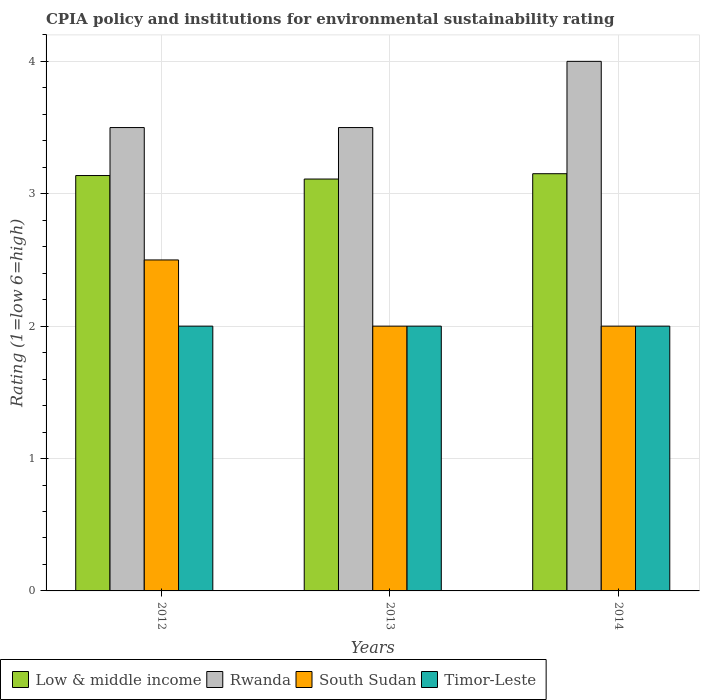How many groups of bars are there?
Provide a succinct answer. 3. Are the number of bars per tick equal to the number of legend labels?
Make the answer very short. Yes. Are the number of bars on each tick of the X-axis equal?
Offer a terse response. Yes. What is the CPIA rating in Timor-Leste in 2012?
Provide a short and direct response. 2. Across all years, what is the minimum CPIA rating in Timor-Leste?
Give a very brief answer. 2. What is the difference between the CPIA rating in Timor-Leste in 2012 and that in 2013?
Provide a succinct answer. 0. In the year 2014, what is the difference between the CPIA rating in Timor-Leste and CPIA rating in Low & middle income?
Keep it short and to the point. -1.15. In how many years, is the CPIA rating in Timor-Leste greater than 2?
Offer a terse response. 0. What is the ratio of the CPIA rating in Low & middle income in 2012 to that in 2014?
Offer a very short reply. 1. What is the difference between the highest and the lowest CPIA rating in South Sudan?
Give a very brief answer. 0.5. In how many years, is the CPIA rating in Timor-Leste greater than the average CPIA rating in Timor-Leste taken over all years?
Provide a succinct answer. 0. What does the 4th bar from the left in 2013 represents?
Ensure brevity in your answer.  Timor-Leste. What does the 1st bar from the right in 2012 represents?
Give a very brief answer. Timor-Leste. Is it the case that in every year, the sum of the CPIA rating in South Sudan and CPIA rating in Timor-Leste is greater than the CPIA rating in Low & middle income?
Offer a terse response. Yes. How many bars are there?
Give a very brief answer. 12. Are all the bars in the graph horizontal?
Keep it short and to the point. No. What is the difference between two consecutive major ticks on the Y-axis?
Your answer should be very brief. 1. Does the graph contain any zero values?
Your answer should be very brief. No. Where does the legend appear in the graph?
Your answer should be very brief. Bottom left. How many legend labels are there?
Give a very brief answer. 4. What is the title of the graph?
Provide a short and direct response. CPIA policy and institutions for environmental sustainability rating. Does "Niger" appear as one of the legend labels in the graph?
Your answer should be compact. No. What is the label or title of the X-axis?
Offer a very short reply. Years. What is the label or title of the Y-axis?
Give a very brief answer. Rating (1=low 6=high). What is the Rating (1=low 6=high) in Low & middle income in 2012?
Provide a succinct answer. 3.14. What is the Rating (1=low 6=high) in Rwanda in 2012?
Ensure brevity in your answer.  3.5. What is the Rating (1=low 6=high) of Timor-Leste in 2012?
Give a very brief answer. 2. What is the Rating (1=low 6=high) in Low & middle income in 2013?
Offer a very short reply. 3.11. What is the Rating (1=low 6=high) of Low & middle income in 2014?
Keep it short and to the point. 3.15. Across all years, what is the maximum Rating (1=low 6=high) of Low & middle income?
Your response must be concise. 3.15. Across all years, what is the maximum Rating (1=low 6=high) of Rwanda?
Your response must be concise. 4. Across all years, what is the maximum Rating (1=low 6=high) of Timor-Leste?
Offer a terse response. 2. Across all years, what is the minimum Rating (1=low 6=high) of Low & middle income?
Your response must be concise. 3.11. Across all years, what is the minimum Rating (1=low 6=high) in Rwanda?
Your response must be concise. 3.5. What is the total Rating (1=low 6=high) of Low & middle income in the graph?
Make the answer very short. 9.4. What is the total Rating (1=low 6=high) in South Sudan in the graph?
Your answer should be very brief. 6.5. What is the difference between the Rating (1=low 6=high) of Low & middle income in 2012 and that in 2013?
Offer a very short reply. 0.03. What is the difference between the Rating (1=low 6=high) in Rwanda in 2012 and that in 2013?
Provide a succinct answer. 0. What is the difference between the Rating (1=low 6=high) in South Sudan in 2012 and that in 2013?
Offer a terse response. 0.5. What is the difference between the Rating (1=low 6=high) of Timor-Leste in 2012 and that in 2013?
Provide a succinct answer. 0. What is the difference between the Rating (1=low 6=high) of Low & middle income in 2012 and that in 2014?
Offer a terse response. -0.01. What is the difference between the Rating (1=low 6=high) in South Sudan in 2012 and that in 2014?
Keep it short and to the point. 0.5. What is the difference between the Rating (1=low 6=high) of Timor-Leste in 2012 and that in 2014?
Your answer should be compact. 0. What is the difference between the Rating (1=low 6=high) in Low & middle income in 2013 and that in 2014?
Give a very brief answer. -0.04. What is the difference between the Rating (1=low 6=high) of Low & middle income in 2012 and the Rating (1=low 6=high) of Rwanda in 2013?
Your answer should be compact. -0.36. What is the difference between the Rating (1=low 6=high) of Low & middle income in 2012 and the Rating (1=low 6=high) of South Sudan in 2013?
Offer a terse response. 1.14. What is the difference between the Rating (1=low 6=high) in Low & middle income in 2012 and the Rating (1=low 6=high) in Timor-Leste in 2013?
Ensure brevity in your answer.  1.14. What is the difference between the Rating (1=low 6=high) of Rwanda in 2012 and the Rating (1=low 6=high) of Timor-Leste in 2013?
Your answer should be very brief. 1.5. What is the difference between the Rating (1=low 6=high) of Low & middle income in 2012 and the Rating (1=low 6=high) of Rwanda in 2014?
Keep it short and to the point. -0.86. What is the difference between the Rating (1=low 6=high) in Low & middle income in 2012 and the Rating (1=low 6=high) in South Sudan in 2014?
Your response must be concise. 1.14. What is the difference between the Rating (1=low 6=high) in Low & middle income in 2012 and the Rating (1=low 6=high) in Timor-Leste in 2014?
Offer a very short reply. 1.14. What is the difference between the Rating (1=low 6=high) of Rwanda in 2012 and the Rating (1=low 6=high) of Timor-Leste in 2014?
Give a very brief answer. 1.5. What is the difference between the Rating (1=low 6=high) of Low & middle income in 2013 and the Rating (1=low 6=high) of Rwanda in 2014?
Give a very brief answer. -0.89. What is the difference between the Rating (1=low 6=high) in Low & middle income in 2013 and the Rating (1=low 6=high) in Timor-Leste in 2014?
Give a very brief answer. 1.11. What is the difference between the Rating (1=low 6=high) of Rwanda in 2013 and the Rating (1=low 6=high) of Timor-Leste in 2014?
Offer a very short reply. 1.5. What is the difference between the Rating (1=low 6=high) in South Sudan in 2013 and the Rating (1=low 6=high) in Timor-Leste in 2014?
Keep it short and to the point. 0. What is the average Rating (1=low 6=high) of Low & middle income per year?
Ensure brevity in your answer.  3.13. What is the average Rating (1=low 6=high) of Rwanda per year?
Ensure brevity in your answer.  3.67. What is the average Rating (1=low 6=high) in South Sudan per year?
Make the answer very short. 2.17. In the year 2012, what is the difference between the Rating (1=low 6=high) in Low & middle income and Rating (1=low 6=high) in Rwanda?
Provide a short and direct response. -0.36. In the year 2012, what is the difference between the Rating (1=low 6=high) of Low & middle income and Rating (1=low 6=high) of South Sudan?
Ensure brevity in your answer.  0.64. In the year 2012, what is the difference between the Rating (1=low 6=high) in Low & middle income and Rating (1=low 6=high) in Timor-Leste?
Keep it short and to the point. 1.14. In the year 2012, what is the difference between the Rating (1=low 6=high) of Rwanda and Rating (1=low 6=high) of South Sudan?
Your answer should be compact. 1. In the year 2012, what is the difference between the Rating (1=low 6=high) of South Sudan and Rating (1=low 6=high) of Timor-Leste?
Your response must be concise. 0.5. In the year 2013, what is the difference between the Rating (1=low 6=high) in Low & middle income and Rating (1=low 6=high) in Rwanda?
Provide a short and direct response. -0.39. In the year 2013, what is the difference between the Rating (1=low 6=high) of Low & middle income and Rating (1=low 6=high) of South Sudan?
Offer a terse response. 1.11. In the year 2014, what is the difference between the Rating (1=low 6=high) in Low & middle income and Rating (1=low 6=high) in Rwanda?
Your answer should be compact. -0.85. In the year 2014, what is the difference between the Rating (1=low 6=high) of Low & middle income and Rating (1=low 6=high) of South Sudan?
Keep it short and to the point. 1.15. In the year 2014, what is the difference between the Rating (1=low 6=high) of Low & middle income and Rating (1=low 6=high) of Timor-Leste?
Your answer should be very brief. 1.15. In the year 2014, what is the difference between the Rating (1=low 6=high) in Rwanda and Rating (1=low 6=high) in Timor-Leste?
Offer a terse response. 2. What is the ratio of the Rating (1=low 6=high) in Low & middle income in 2012 to that in 2013?
Give a very brief answer. 1.01. What is the ratio of the Rating (1=low 6=high) in South Sudan in 2012 to that in 2013?
Ensure brevity in your answer.  1.25. What is the ratio of the Rating (1=low 6=high) in Timor-Leste in 2012 to that in 2013?
Keep it short and to the point. 1. What is the ratio of the Rating (1=low 6=high) of Rwanda in 2012 to that in 2014?
Your answer should be very brief. 0.88. What is the ratio of the Rating (1=low 6=high) of South Sudan in 2012 to that in 2014?
Offer a terse response. 1.25. What is the ratio of the Rating (1=low 6=high) of Low & middle income in 2013 to that in 2014?
Offer a very short reply. 0.99. What is the difference between the highest and the second highest Rating (1=low 6=high) in Low & middle income?
Make the answer very short. 0.01. What is the difference between the highest and the second highest Rating (1=low 6=high) in South Sudan?
Keep it short and to the point. 0.5. What is the difference between the highest and the lowest Rating (1=low 6=high) of Low & middle income?
Keep it short and to the point. 0.04. What is the difference between the highest and the lowest Rating (1=low 6=high) of Rwanda?
Ensure brevity in your answer.  0.5. 